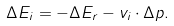<formula> <loc_0><loc_0><loc_500><loc_500>\Delta E _ { i } = - \Delta E _ { r } - v _ { i } \cdot \Delta p .</formula> 